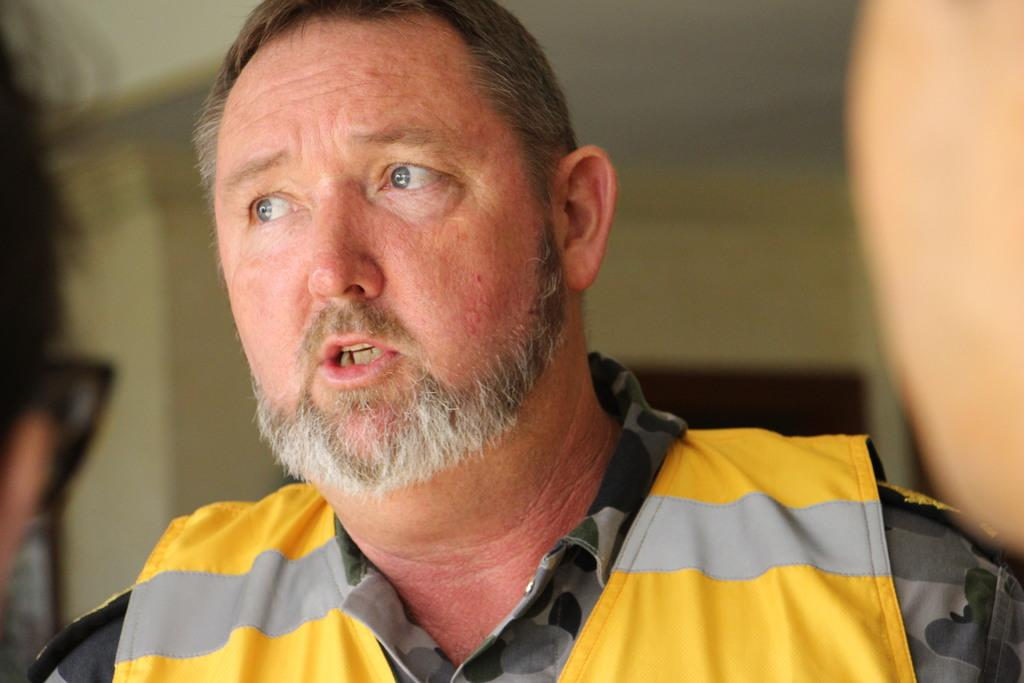Who is present in the image? There is a man in the image. What is the man wearing? The man is wearing clothes. What is the man doing in the image? The man is talking. Can you describe the background of the image? The background of the image is blurred. How many cherries are hanging from the man's hat in the image? There are no cherries present in the image, nor are there any hanging from the man's hat. 